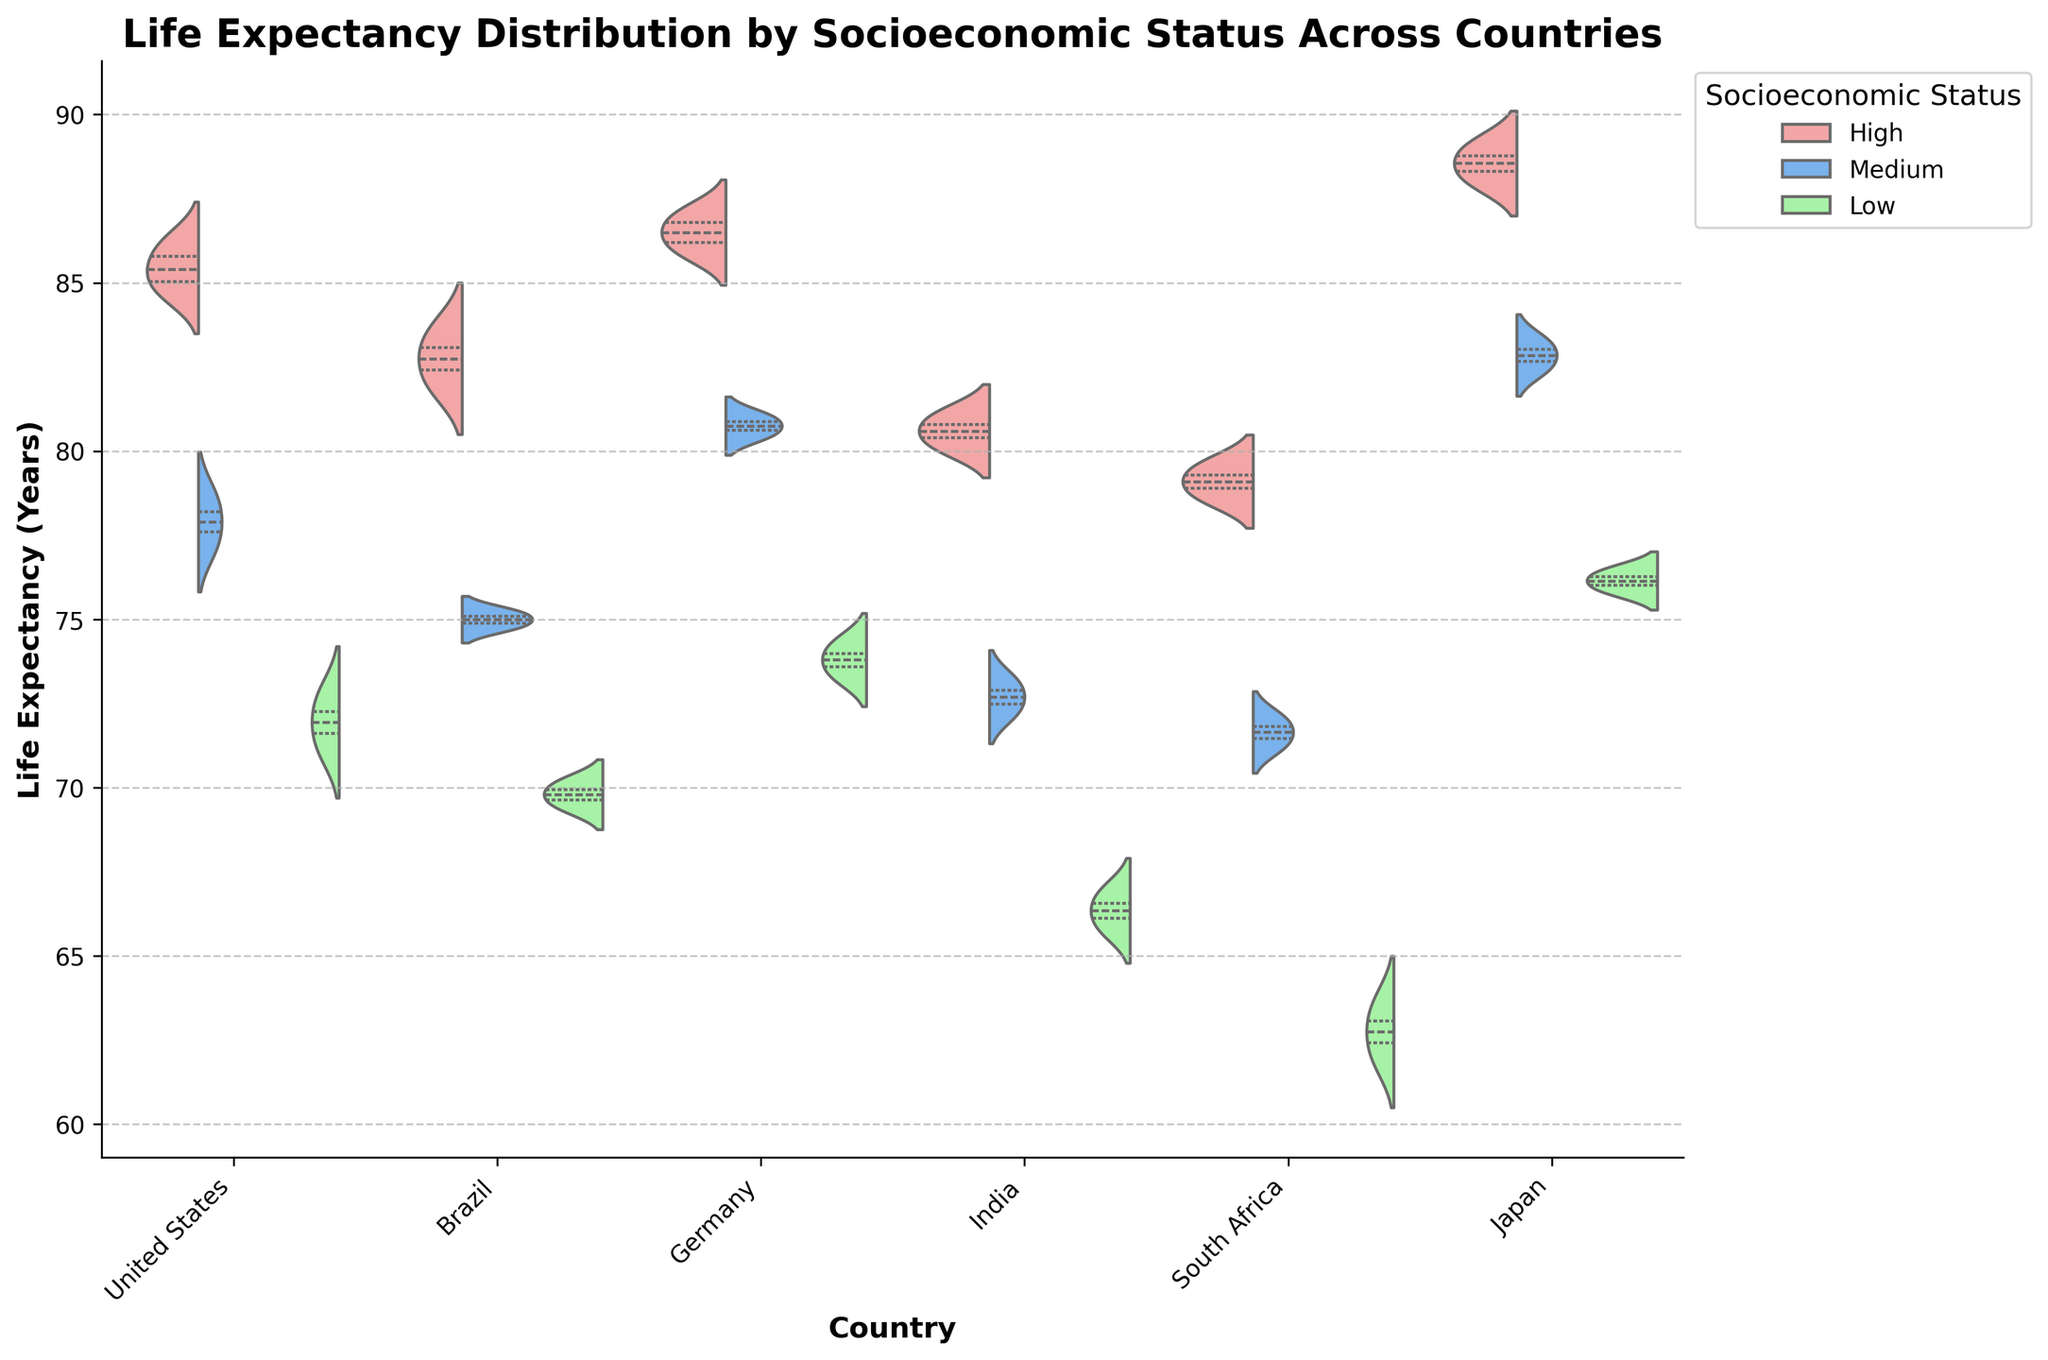What is the title of the figure? The title is written at the top of the figure. It describes the subject of the data displayed in the chart.
Answer: Life Expectancy Distribution by Socioeconomic Status Across Countries What is the range of life expectancy values depicted in the figure? You can see the range by looking at the y-axis, which shows the life expectancy in years. The minimum value is 60 and the maximum value is 95.
Answer: 60 to 95 Which country has the highest life expectancy in the high socioeconomic status category? By examining the violin plots for each country, the violin plot with the highest value in the high socioeconomic status is for Japan.
Answer: Japan How does the life expectancy in the low socioeconomic status group in the United States compare to that in Germany? Compare the median lines in the low socioeconomic status category for both countries; the median in the United States is lower than in Germany.
Answer: The United States has a lower life expectancy than Germany in the low socioeconomic status group What is the difference in median life expectancy between the high and low socioeconomic statuses in Brazil? The median life expectancy for the high status in Brazil seems around 82, and for the low status, it's about 70. Calculating the difference: 82 - 70 = 12 years.
Answer: 12 years Which socioeconomic status group shows the widest range of life expectancy values in South Africa? For South Africa, looking at the width of the violin plots, the low socioeconomic status shows the widest spread of values.
Answer: Low Are the life expectancy distributions in different socioeconomic statuses completely separated in the United States? If the violin plots for high, medium, and low statuses between the United States are separate without overlap, then they are completely separated. Observing the plot, they are not completely separated with some overlap.
Answer: No Which country shows the highest median life expectancy for the medium socioeconomic status group? By focusing on the median lines in the medium socioeconomic status violin plots, Japan appears to have the highest median value.
Answer: Japan In which country does the medium socioeconomic status have a similar life expectancy distribution most closely aligned with the high socioeconomic status? Comparing the violin plots for medium and high statuses across countries, Germany shows that the medium status is closely aligned with the high status.
Answer: Germany 